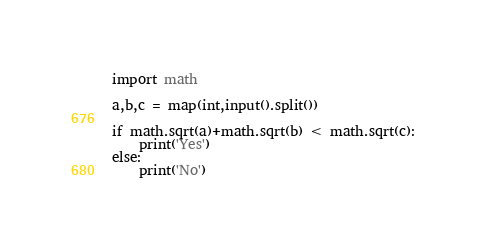<code> <loc_0><loc_0><loc_500><loc_500><_Python_>import math

a,b,c = map(int,input().split())

if math.sqrt(a)+math.sqrt(b) < math.sqrt(c):
    print('Yes')
else:
    print('No')
</code> 